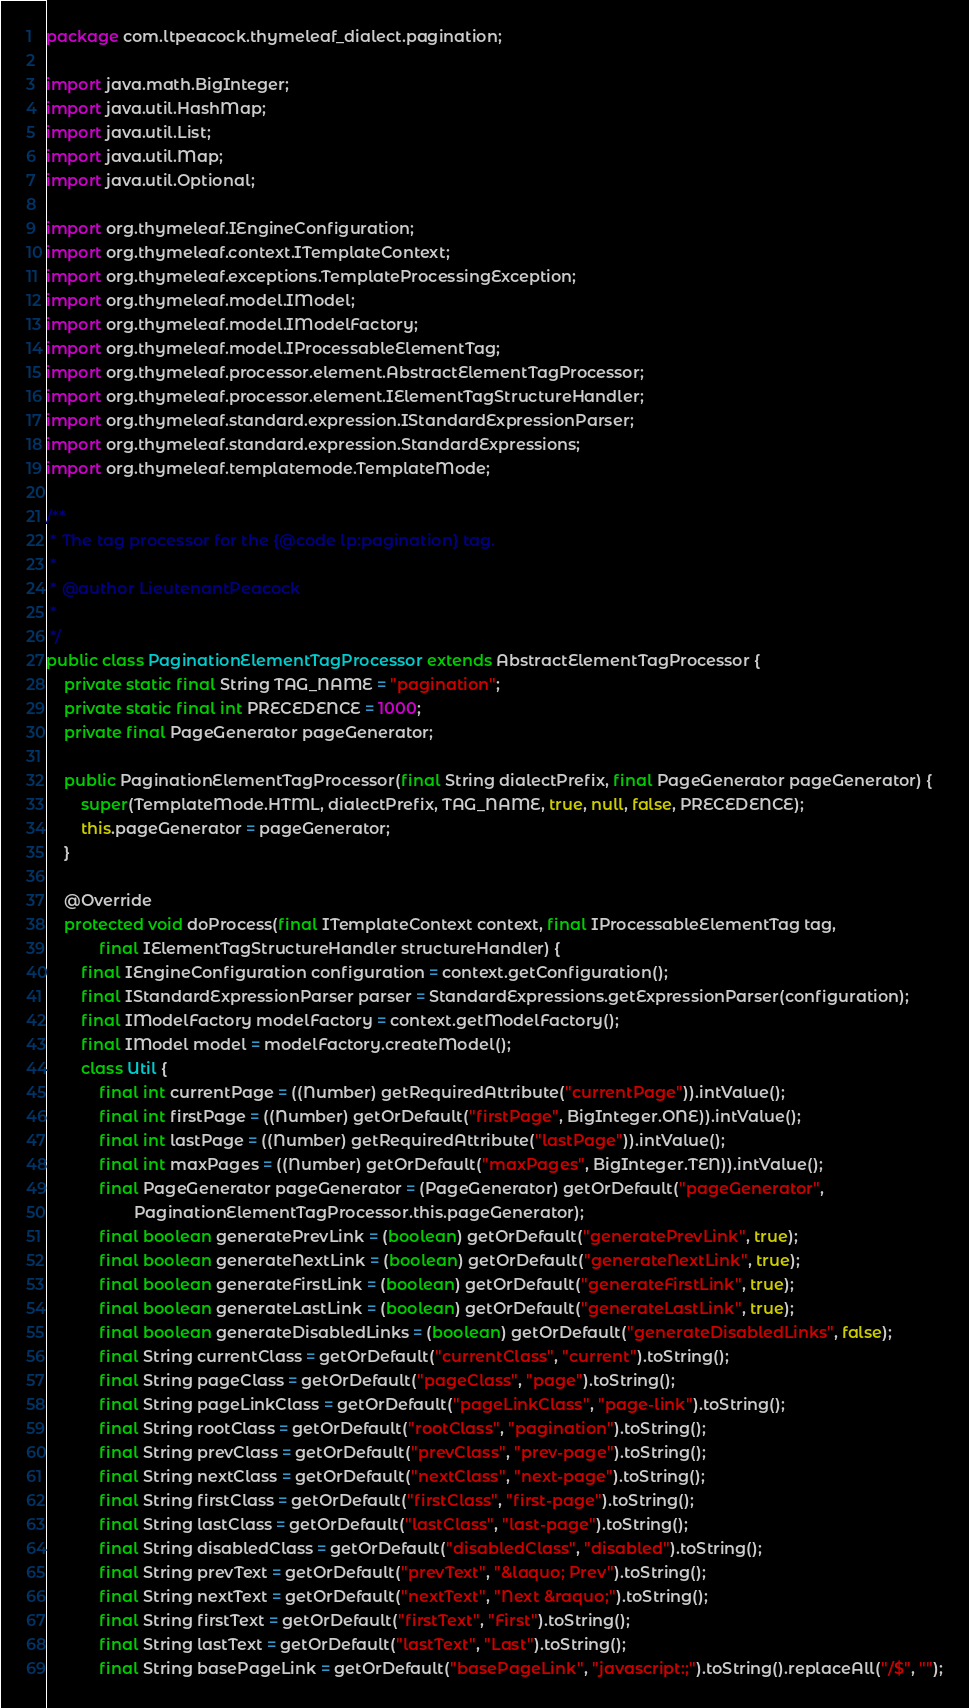Convert code to text. <code><loc_0><loc_0><loc_500><loc_500><_Java_>package com.ltpeacock.thymeleaf_dialect.pagination;

import java.math.BigInteger;
import java.util.HashMap;
import java.util.List;
import java.util.Map;
import java.util.Optional;

import org.thymeleaf.IEngineConfiguration;
import org.thymeleaf.context.ITemplateContext;
import org.thymeleaf.exceptions.TemplateProcessingException;
import org.thymeleaf.model.IModel;
import org.thymeleaf.model.IModelFactory;
import org.thymeleaf.model.IProcessableElementTag;
import org.thymeleaf.processor.element.AbstractElementTagProcessor;
import org.thymeleaf.processor.element.IElementTagStructureHandler;
import org.thymeleaf.standard.expression.IStandardExpressionParser;
import org.thymeleaf.standard.expression.StandardExpressions;
import org.thymeleaf.templatemode.TemplateMode;

/**
 * The tag processor for the {@code lp:pagination} tag.
 * 
 * @author LieutenantPeacock
 *
 */
public class PaginationElementTagProcessor extends AbstractElementTagProcessor {
	private static final String TAG_NAME = "pagination";
	private static final int PRECEDENCE = 1000;
	private final PageGenerator pageGenerator;

	public PaginationElementTagProcessor(final String dialectPrefix, final PageGenerator pageGenerator) {
		super(TemplateMode.HTML, dialectPrefix, TAG_NAME, true, null, false, PRECEDENCE);
		this.pageGenerator = pageGenerator;
	}

	@Override
	protected void doProcess(final ITemplateContext context, final IProcessableElementTag tag,
			final IElementTagStructureHandler structureHandler) {
		final IEngineConfiguration configuration = context.getConfiguration();
		final IStandardExpressionParser parser = StandardExpressions.getExpressionParser(configuration);
		final IModelFactory modelFactory = context.getModelFactory();
		final IModel model = modelFactory.createModel();
		class Util {
			final int currentPage = ((Number) getRequiredAttribute("currentPage")).intValue();
			final int firstPage = ((Number) getOrDefault("firstPage", BigInteger.ONE)).intValue();
			final int lastPage = ((Number) getRequiredAttribute("lastPage")).intValue();
			final int maxPages = ((Number) getOrDefault("maxPages", BigInteger.TEN)).intValue();
			final PageGenerator pageGenerator = (PageGenerator) getOrDefault("pageGenerator",
					PaginationElementTagProcessor.this.pageGenerator);
			final boolean generatePrevLink = (boolean) getOrDefault("generatePrevLink", true);
			final boolean generateNextLink = (boolean) getOrDefault("generateNextLink", true);
			final boolean generateFirstLink = (boolean) getOrDefault("generateFirstLink", true);
			final boolean generateLastLink = (boolean) getOrDefault("generateLastLink", true);
			final boolean generateDisabledLinks = (boolean) getOrDefault("generateDisabledLinks", false);
			final String currentClass = getOrDefault("currentClass", "current").toString();
			final String pageClass = getOrDefault("pageClass", "page").toString();
			final String pageLinkClass = getOrDefault("pageLinkClass", "page-link").toString();
			final String rootClass = getOrDefault("rootClass", "pagination").toString();
			final String prevClass = getOrDefault("prevClass", "prev-page").toString();
			final String nextClass = getOrDefault("nextClass", "next-page").toString();
			final String firstClass = getOrDefault("firstClass", "first-page").toString();
			final String lastClass = getOrDefault("lastClass", "last-page").toString();
			final String disabledClass = getOrDefault("disabledClass", "disabled").toString();
			final String prevText = getOrDefault("prevText", "&laquo; Prev").toString();
			final String nextText = getOrDefault("nextText", "Next &raquo;").toString();
			final String firstText = getOrDefault("firstText", "First").toString();
			final String lastText = getOrDefault("lastText", "Last").toString();
			final String basePageLink = getOrDefault("basePageLink", "javascript:;").toString().replaceAll("/$", "");
</code> 